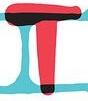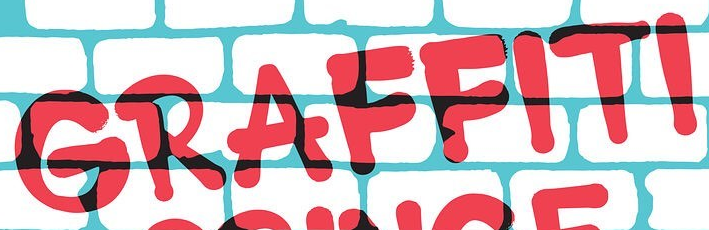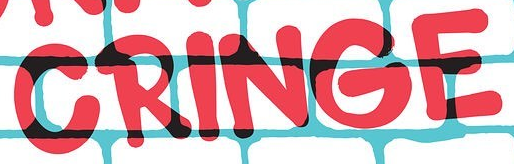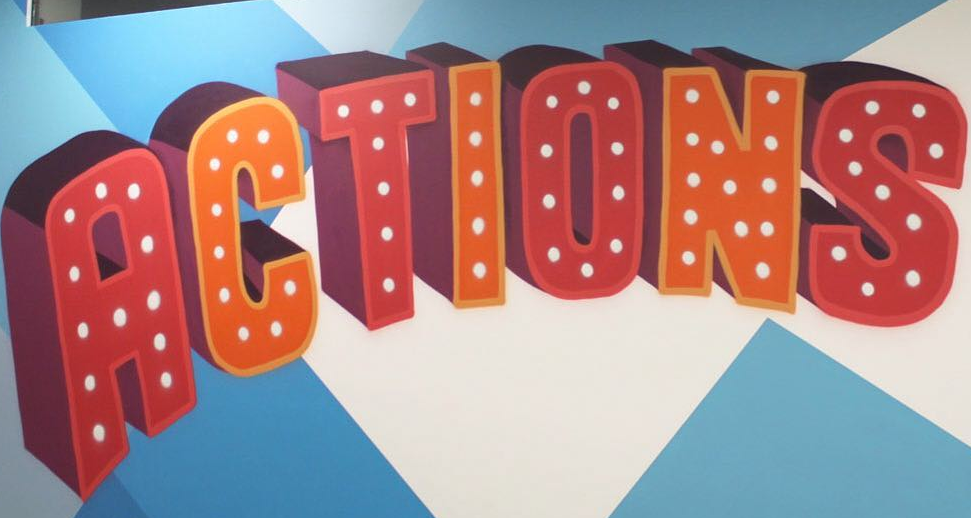Identify the words shown in these images in order, separated by a semicolon. T; GRAFFITI; CRINGE; ACTIONS 